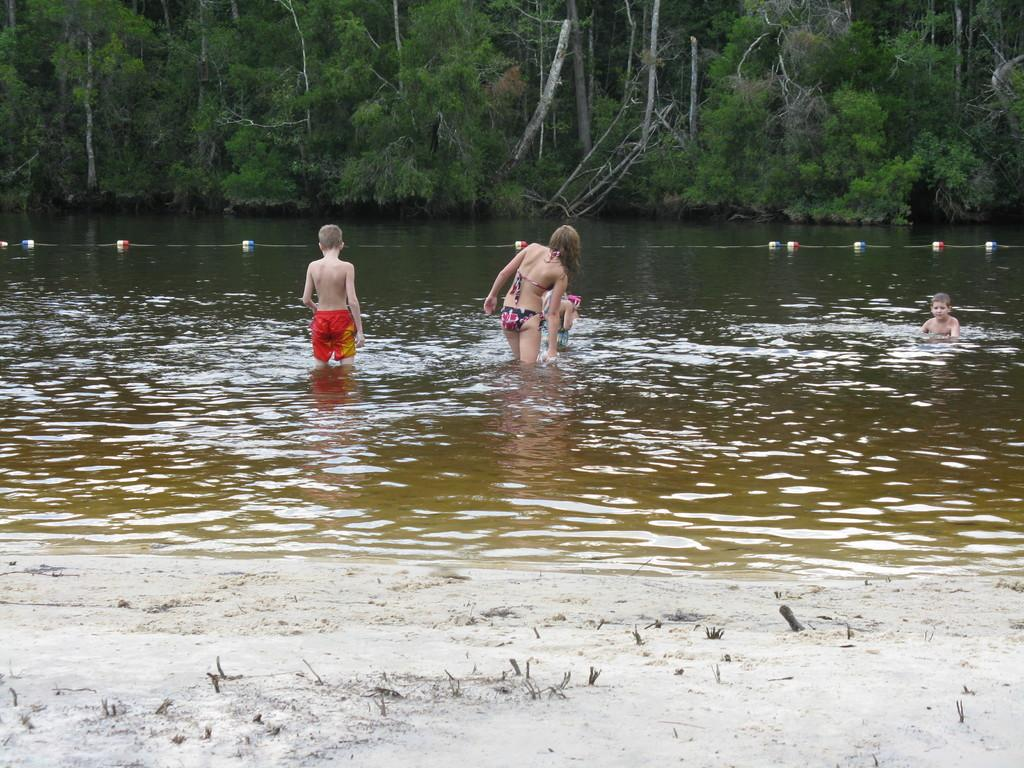What are the people in the image doing? The people in the image are standing and playing in the water. What can be seen in the middle of the image? There is a holding rope in the middle of the image. What is visible in the background of the image? There are many trees visible in the background. Where is the cobweb located in the image? There is no cobweb present in the image. What type of chair can be seen in the image? There is no chair present in the image. 